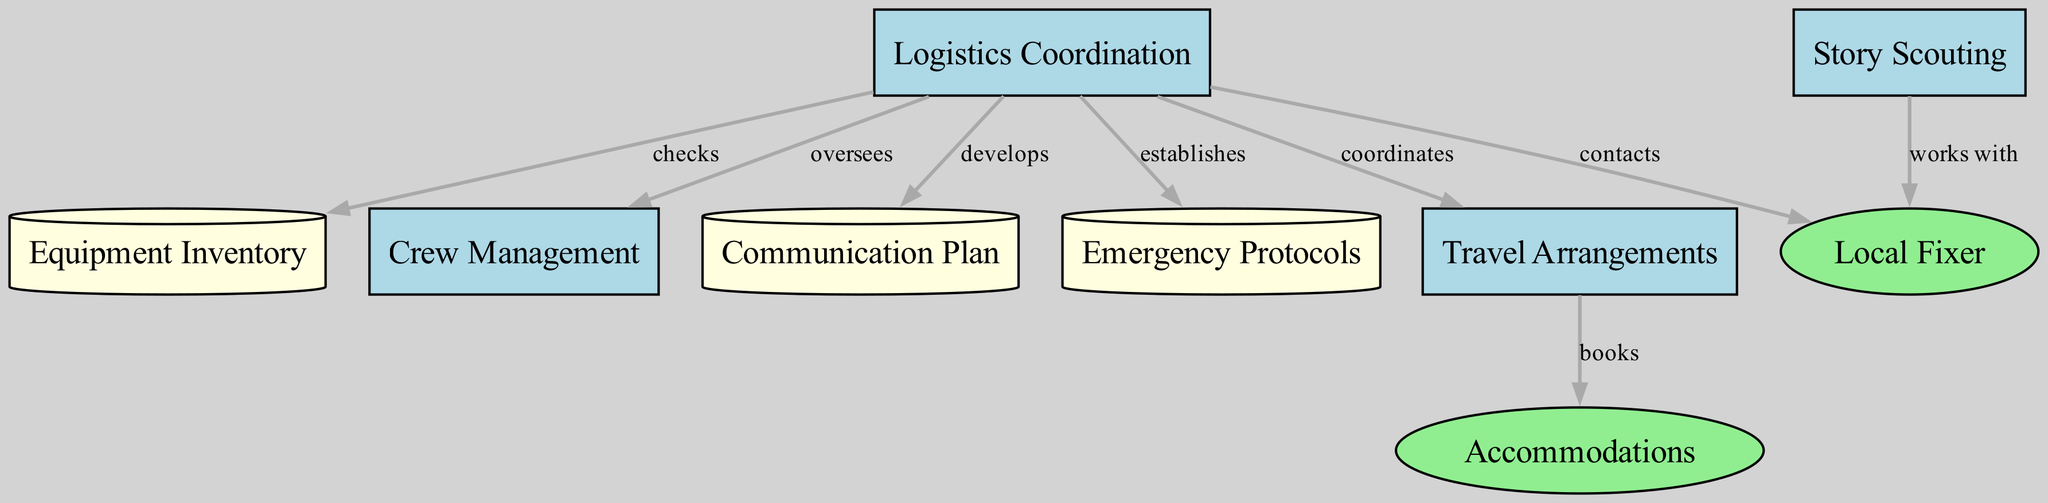What is the label of the data store node? The diagram contains a node of type "dataStore," and its label is directly specified as "Communication Plan."
Answer: Communication Plan How many resource nodes are present in the diagram? By counting the nodes of type "resource," we find there are two resources: "Local Fixer" and "Accommodations."
Answer: 2 Which node checks the equipment inventory? The "Logistics Coordination" node is indicated to have an edge labeled "checks" pointing to "Equipment Inventory," which signifies it performs this action.
Answer: Logistics Coordination What is the relationship between "Travel Arrangements" and "Accommodations"? The edge labeled "books" connecting "Travel Arrangements" to "Accommodations" indicates that the travel arrangements made by the logistics coordination lead to booking accommodations.
Answer: books Which process oversees crew management? The edge labeled "oversees" connects "Logistics Coordination" to "Crew Management," indicating that logistics coordination is responsible for overseeing this process.
Answer: Logistics Coordination Which process works with the local fixer for story scouting? The diagram shows a connection labeled "works with" from "Story Scouting" pointing to "Local Fixer," meaning story scouting involves collaborating with the local fixer.
Answer: Story Scouting What type of node is "Emergency Protocols"? As per the diagram, "Emergency Protocols" is categorized under "dataStore" type, which is represented in a cylindrical shape.
Answer: dataStore Which node develops the communication plan? The "Logistics Coordination" node has a directed edge labeled "develops" toward the "Communication Plan," indicating its role in the development of this plan.
Answer: Logistics Coordination How many edges are shown in the diagram? The diagram includes a total of eight edges connecting various nodes, representing different relationships and actions within the process.
Answer: 8 